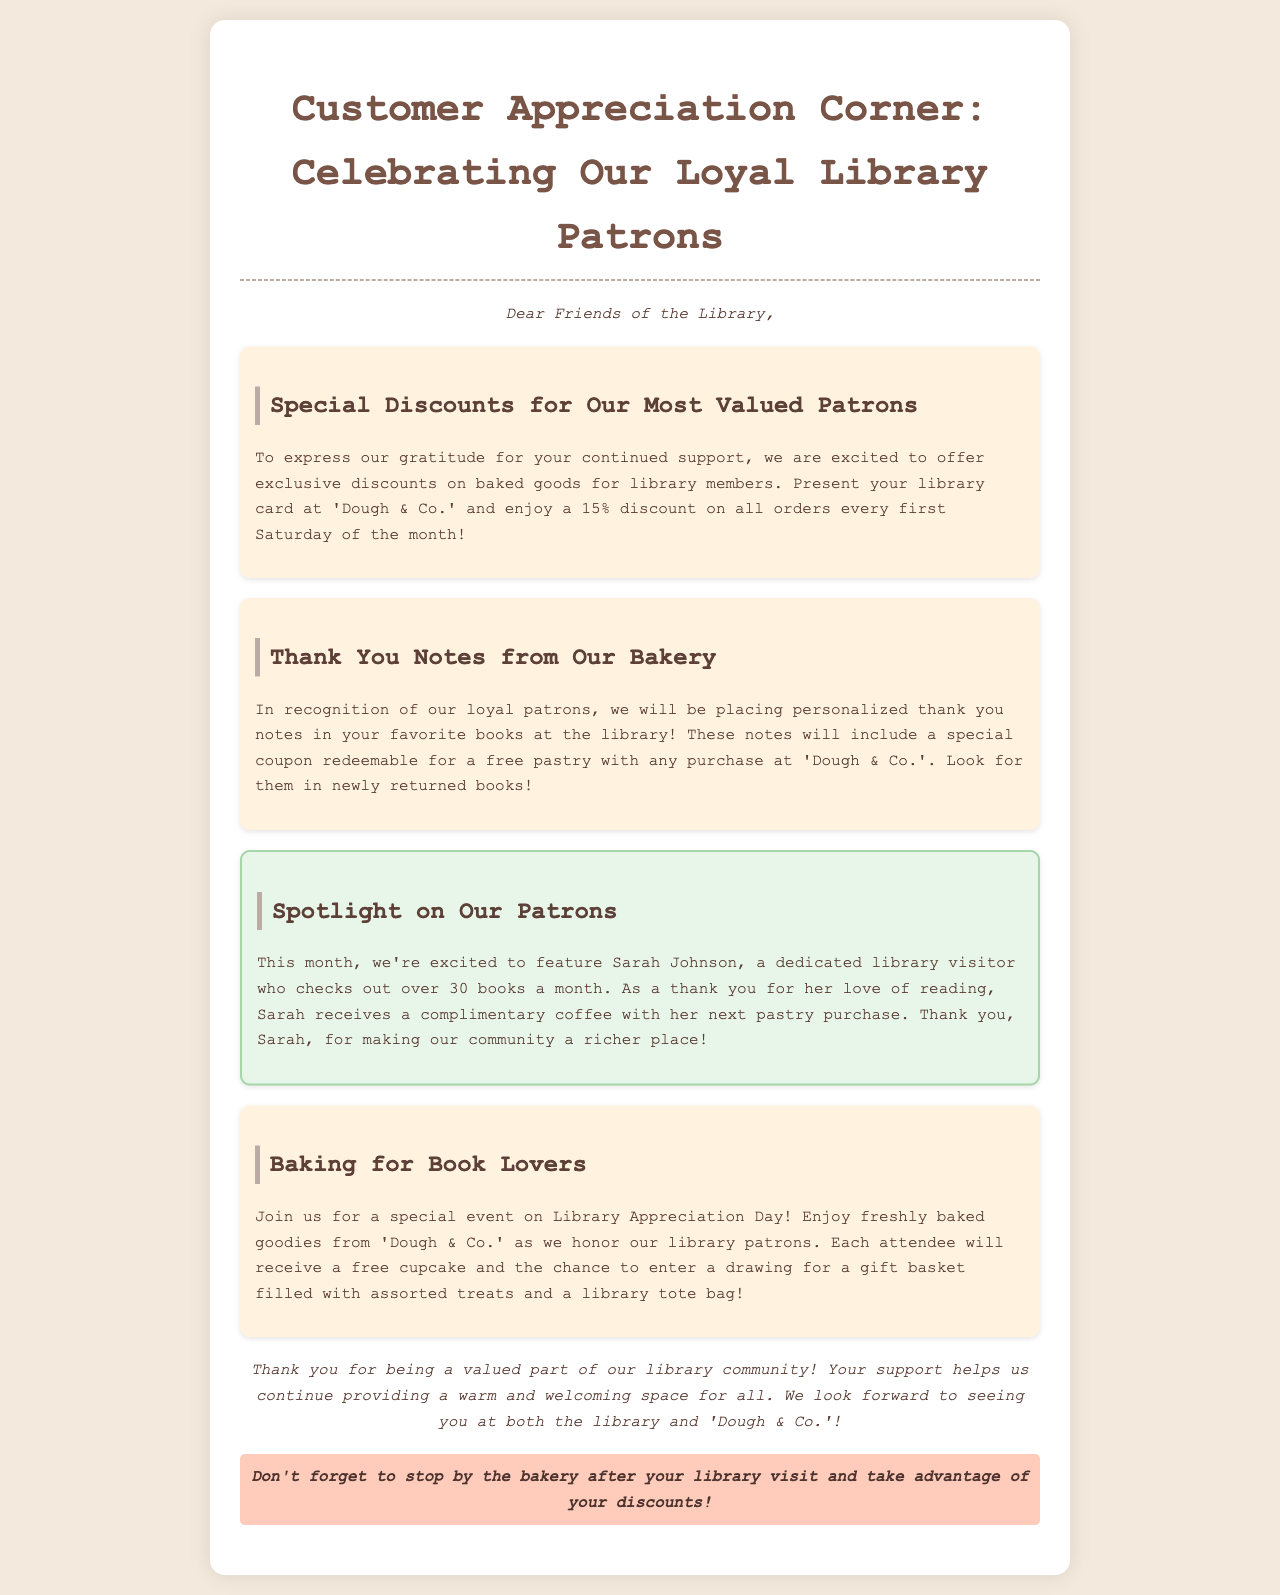What is the discount percentage for library members? The document states that library members can enjoy a 15% discount on all orders every first Saturday of the month.
Answer: 15% Who is the featured patron this month? The spotlight section mentions Sarah Johnson as this month's featured patron.
Answer: Sarah Johnson What special event is mentioned in the document? The document refers to a special event on Library Appreciation Day where baked goodies will be served.
Answer: Library Appreciation Day What type of coupon will be included in thank you notes? The thank you notes will include a special coupon redeemable for a free pastry with any purchase at 'Dough & Co.'.
Answer: free pastry How often can library members receive discounts? Library members can receive the discounts every first Saturday of the month as stated in the document.
Answer: every first Saturday of the month What will attendees receive at the special event? Each attendee will receive a free cupcake at the Library Appreciation Day event.
Answer: free cupcake 